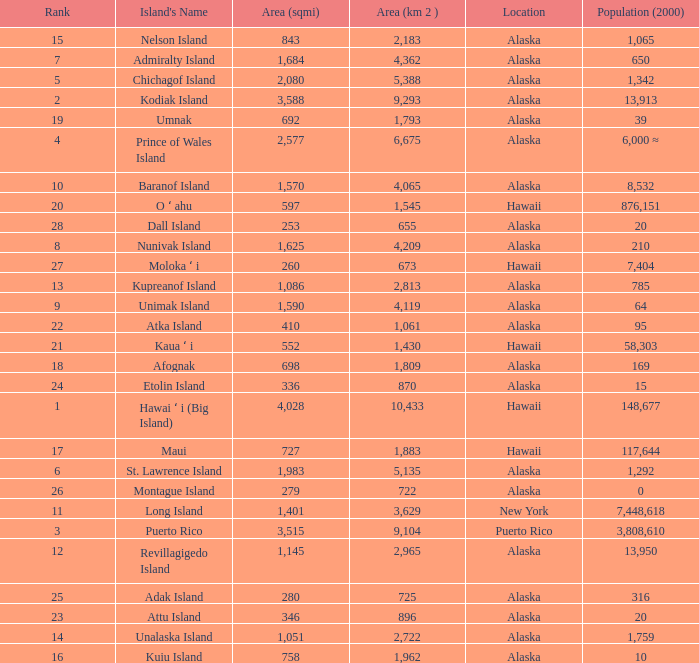What is the highest rank for Nelson Island with area more than 2,183? None. 